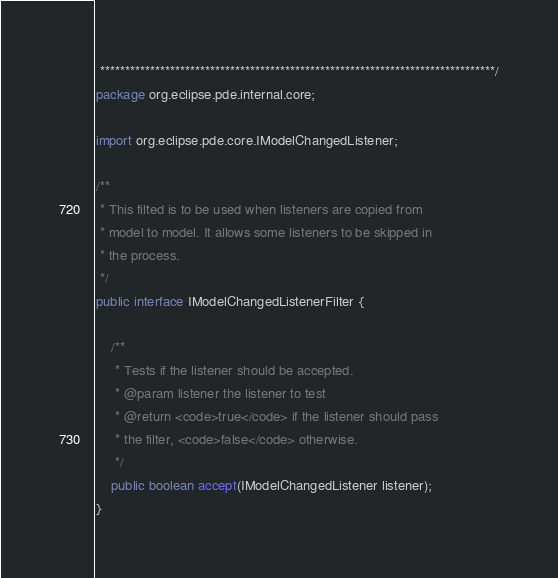Convert code to text. <code><loc_0><loc_0><loc_500><loc_500><_Java_> *******************************************************************************/
package org.eclipse.pde.internal.core;

import org.eclipse.pde.core.IModelChangedListener;

/**
 * This filted is to be used when listeners are copied from
 * model to model. It allows some listeners to be skipped in
 * the process.
 */
public interface IModelChangedListenerFilter {

    /**
	 * Tests if the listener should be accepted.
	 * @param listener the listener to test
	 * @return <code>true</code> if the listener should pass
	 * the filter, <code>false</code> otherwise.
	 */
    public boolean accept(IModelChangedListener listener);
}
</code> 